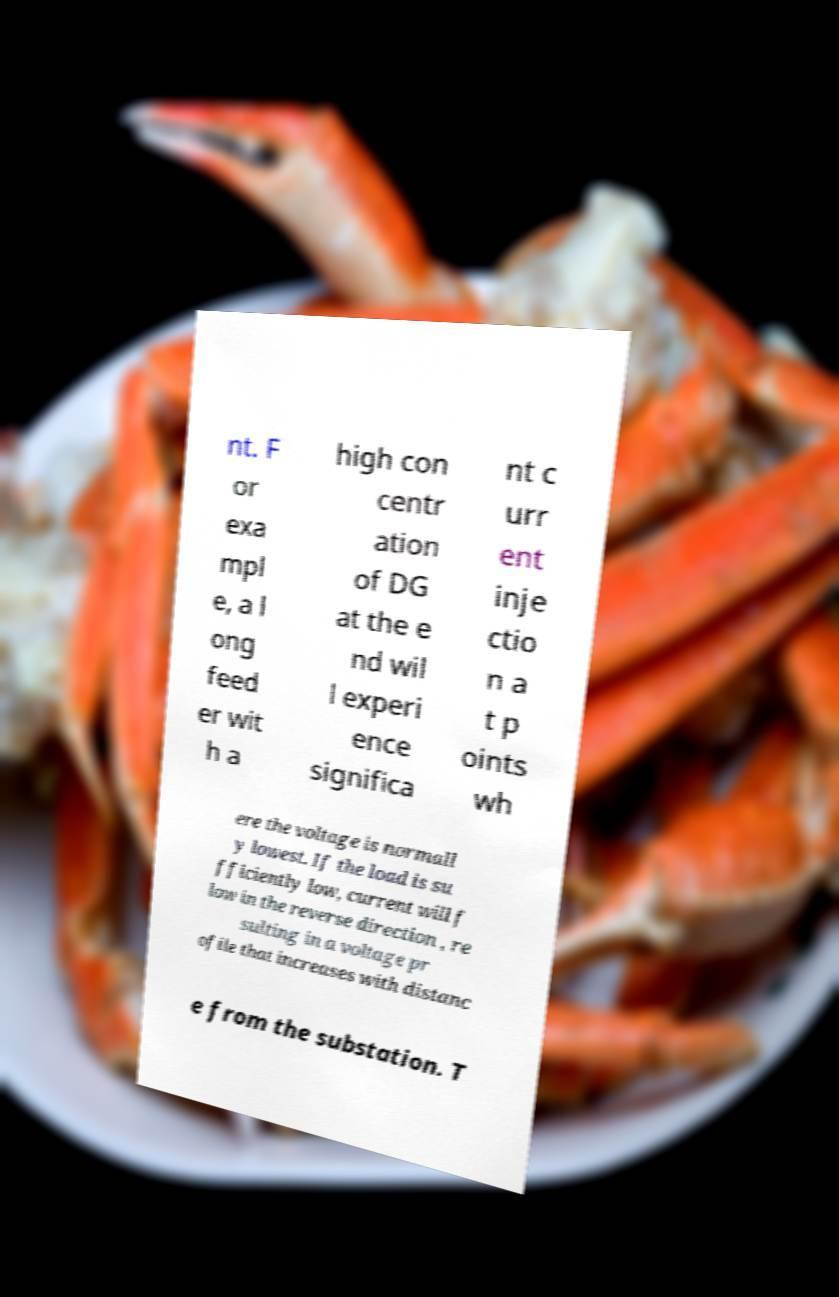Please identify and transcribe the text found in this image. nt. F or exa mpl e, a l ong feed er wit h a high con centr ation of DG at the e nd wil l experi ence significa nt c urr ent inje ctio n a t p oints wh ere the voltage is normall y lowest. If the load is su fficiently low, current will f low in the reverse direction , re sulting in a voltage pr ofile that increases with distanc e from the substation. T 